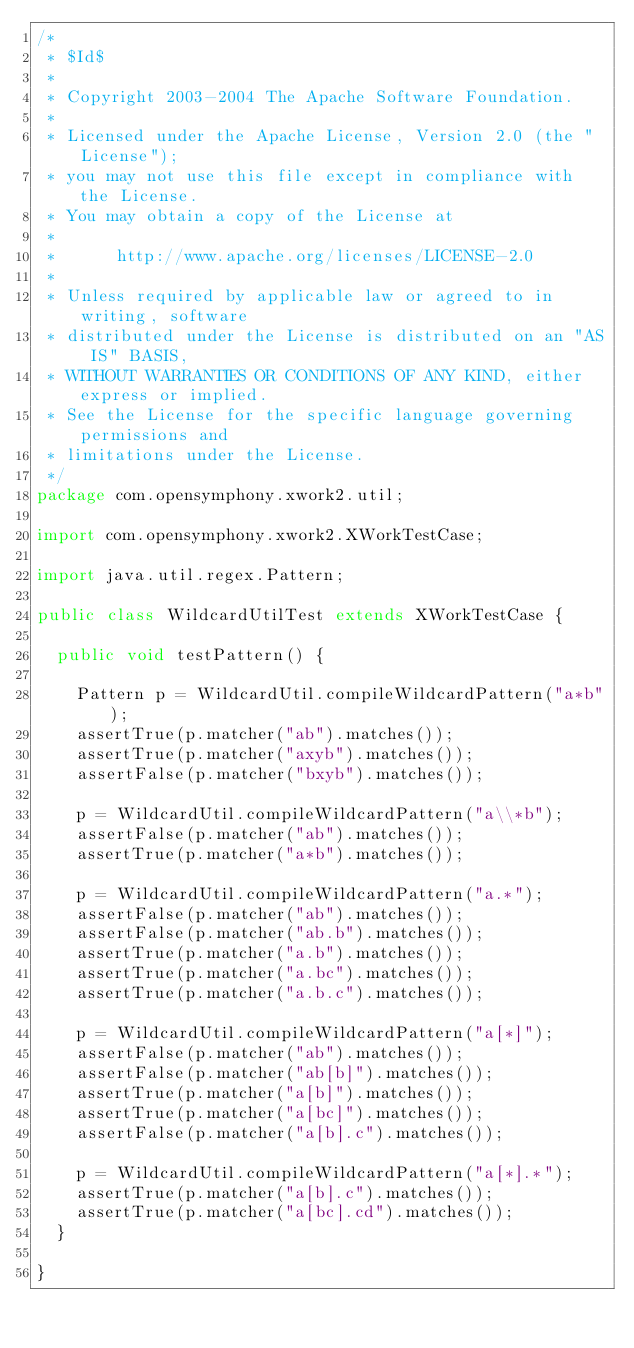Convert code to text. <code><loc_0><loc_0><loc_500><loc_500><_Java_>/*
 * $Id$
 *
 * Copyright 2003-2004 The Apache Software Foundation.
 *
 * Licensed under the Apache License, Version 2.0 (the "License");
 * you may not use this file except in compliance with the License.
 * You may obtain a copy of the License at
 *
 *      http://www.apache.org/licenses/LICENSE-2.0
 *
 * Unless required by applicable law or agreed to in writing, software
 * distributed under the License is distributed on an "AS IS" BASIS,
 * WITHOUT WARRANTIES OR CONDITIONS OF ANY KIND, either express or implied.
 * See the License for the specific language governing permissions and
 * limitations under the License.
 */
package com.opensymphony.xwork2.util;

import com.opensymphony.xwork2.XWorkTestCase;

import java.util.regex.Pattern;

public class WildcardUtilTest extends XWorkTestCase {
	
	public void testPattern() {
		
		Pattern p = WildcardUtil.compileWildcardPattern("a*b");
		assertTrue(p.matcher("ab").matches());
		assertTrue(p.matcher("axyb").matches());
		assertFalse(p.matcher("bxyb").matches());
		
		p = WildcardUtil.compileWildcardPattern("a\\*b");
		assertFalse(p.matcher("ab").matches());
		assertTrue(p.matcher("a*b").matches());
		
		p = WildcardUtil.compileWildcardPattern("a.*");
		assertFalse(p.matcher("ab").matches());
		assertFalse(p.matcher("ab.b").matches());
		assertTrue(p.matcher("a.b").matches());
		assertTrue(p.matcher("a.bc").matches());
		assertTrue(p.matcher("a.b.c").matches());
		
		p = WildcardUtil.compileWildcardPattern("a[*]");
		assertFalse(p.matcher("ab").matches());
		assertFalse(p.matcher("ab[b]").matches());
		assertTrue(p.matcher("a[b]").matches());
		assertTrue(p.matcher("a[bc]").matches());
		assertFalse(p.matcher("a[b].c").matches());

		p = WildcardUtil.compileWildcardPattern("a[*].*");
		assertTrue(p.matcher("a[b].c").matches());
		assertTrue(p.matcher("a[bc].cd").matches());
	}

}
</code> 